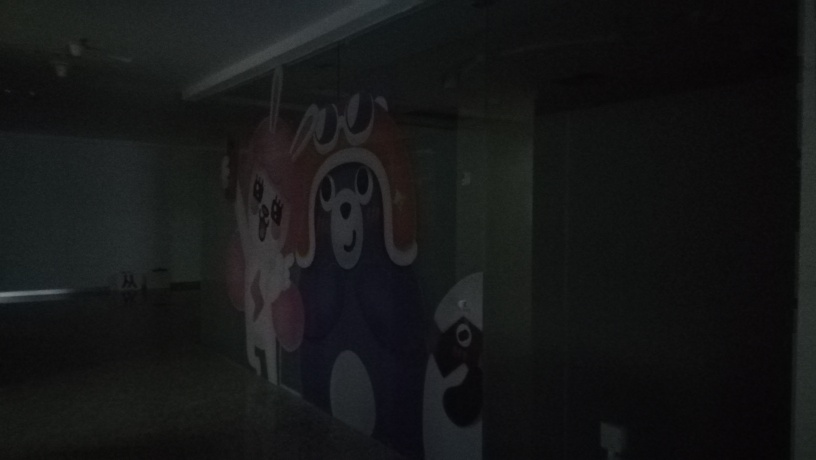Can you describe the artwork on the wall? The artwork on the wall features playful and abstract characters. Their bold outlines and cheerful design imply that the artwork is meant to imbue a sense of fun and creativity in the space, though the details are hard to make out due to the low lighting. 